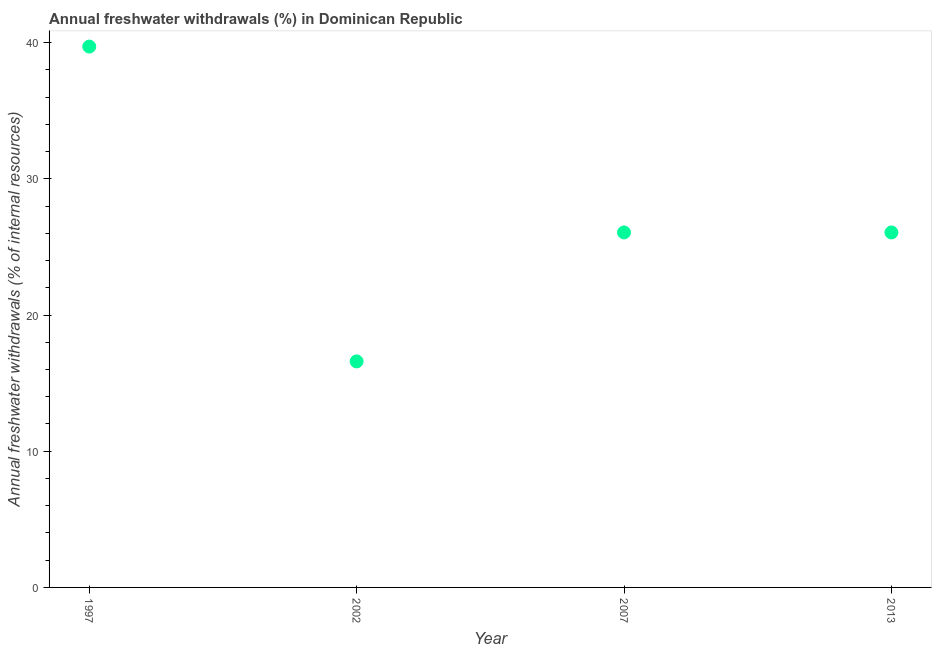What is the annual freshwater withdrawals in 2013?
Offer a very short reply. 26.06. Across all years, what is the maximum annual freshwater withdrawals?
Offer a very short reply. 39.71. Across all years, what is the minimum annual freshwater withdrawals?
Offer a very short reply. 16.6. In which year was the annual freshwater withdrawals minimum?
Provide a short and direct response. 2002. What is the sum of the annual freshwater withdrawals?
Give a very brief answer. 108.43. What is the difference between the annual freshwater withdrawals in 2002 and 2013?
Offer a terse response. -9.47. What is the average annual freshwater withdrawals per year?
Your response must be concise. 27.11. What is the median annual freshwater withdrawals?
Ensure brevity in your answer.  26.06. In how many years, is the annual freshwater withdrawals greater than 36 %?
Keep it short and to the point. 1. What is the ratio of the annual freshwater withdrawals in 2002 to that in 2007?
Give a very brief answer. 0.64. Is the difference between the annual freshwater withdrawals in 1997 and 2002 greater than the difference between any two years?
Give a very brief answer. Yes. What is the difference between the highest and the second highest annual freshwater withdrawals?
Your answer should be very brief. 13.65. What is the difference between the highest and the lowest annual freshwater withdrawals?
Keep it short and to the point. 23.11. Does the annual freshwater withdrawals monotonically increase over the years?
Your response must be concise. No. Are the values on the major ticks of Y-axis written in scientific E-notation?
Your answer should be very brief. No. Does the graph contain grids?
Keep it short and to the point. No. What is the title of the graph?
Your response must be concise. Annual freshwater withdrawals (%) in Dominican Republic. What is the label or title of the Y-axis?
Keep it short and to the point. Annual freshwater withdrawals (% of internal resources). What is the Annual freshwater withdrawals (% of internal resources) in 1997?
Offer a terse response. 39.71. What is the Annual freshwater withdrawals (% of internal resources) in 2002?
Offer a very short reply. 16.6. What is the Annual freshwater withdrawals (% of internal resources) in 2007?
Provide a succinct answer. 26.06. What is the Annual freshwater withdrawals (% of internal resources) in 2013?
Your answer should be compact. 26.06. What is the difference between the Annual freshwater withdrawals (% of internal resources) in 1997 and 2002?
Offer a very short reply. 23.11. What is the difference between the Annual freshwater withdrawals (% of internal resources) in 1997 and 2007?
Your answer should be compact. 13.65. What is the difference between the Annual freshwater withdrawals (% of internal resources) in 1997 and 2013?
Ensure brevity in your answer.  13.65. What is the difference between the Annual freshwater withdrawals (% of internal resources) in 2002 and 2007?
Your response must be concise. -9.47. What is the difference between the Annual freshwater withdrawals (% of internal resources) in 2002 and 2013?
Your response must be concise. -9.47. What is the difference between the Annual freshwater withdrawals (% of internal resources) in 2007 and 2013?
Your answer should be compact. 0. What is the ratio of the Annual freshwater withdrawals (% of internal resources) in 1997 to that in 2002?
Provide a short and direct response. 2.39. What is the ratio of the Annual freshwater withdrawals (% of internal resources) in 1997 to that in 2007?
Give a very brief answer. 1.52. What is the ratio of the Annual freshwater withdrawals (% of internal resources) in 1997 to that in 2013?
Your answer should be compact. 1.52. What is the ratio of the Annual freshwater withdrawals (% of internal resources) in 2002 to that in 2007?
Your answer should be very brief. 0.64. What is the ratio of the Annual freshwater withdrawals (% of internal resources) in 2002 to that in 2013?
Ensure brevity in your answer.  0.64. What is the ratio of the Annual freshwater withdrawals (% of internal resources) in 2007 to that in 2013?
Provide a short and direct response. 1. 